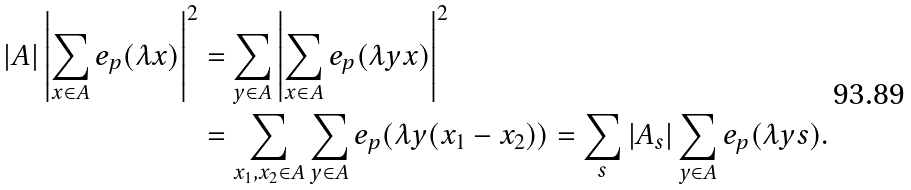<formula> <loc_0><loc_0><loc_500><loc_500>| A | \left | \sum _ { x \in A } e _ { p } ( \lambda x ) \right | ^ { 2 } & = \sum _ { y \in A } \left | \sum _ { x \in A } e _ { p } ( \lambda y x ) \right | ^ { 2 } \\ & = \sum _ { x _ { 1 } , x _ { 2 } \in A } \sum _ { y \in A } e _ { p } ( \lambda y ( x _ { 1 } - x _ { 2 } ) ) = \sum _ { s } | A _ { s } | \sum _ { y \in A } e _ { p } ( \lambda y s ) . \\</formula> 